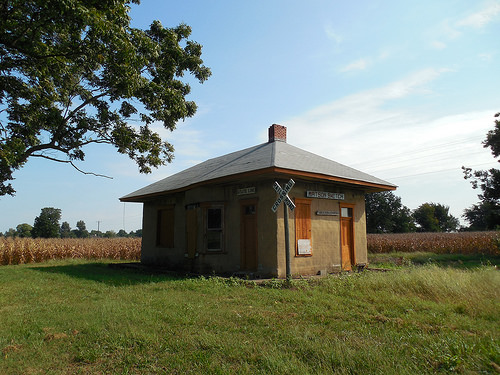<image>
Can you confirm if the building is on the grass? Yes. Looking at the image, I can see the building is positioned on top of the grass, with the grass providing support. Is the tree in front of the sign? No. The tree is not in front of the sign. The spatial positioning shows a different relationship between these objects. 